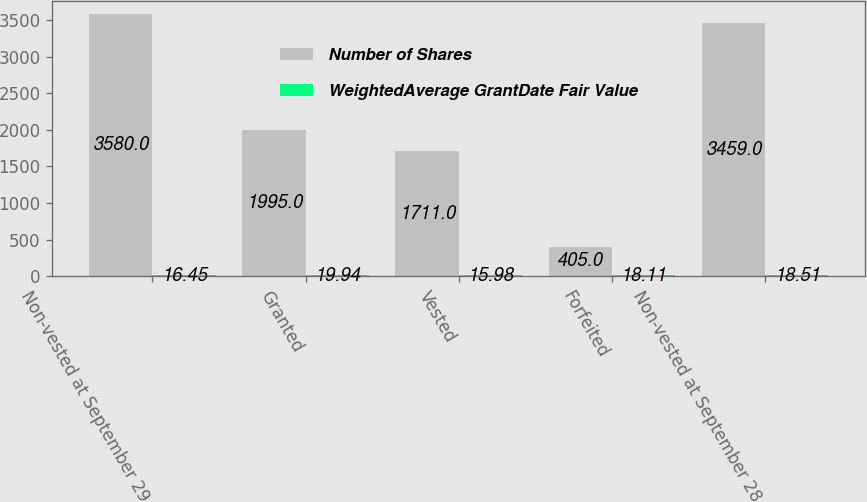Convert chart. <chart><loc_0><loc_0><loc_500><loc_500><stacked_bar_chart><ecel><fcel>Non-vested at September 29<fcel>Granted<fcel>Vested<fcel>Forfeited<fcel>Non-vested at September 28<nl><fcel>Number of Shares<fcel>3580<fcel>1995<fcel>1711<fcel>405<fcel>3459<nl><fcel>WeightedAverage GrantDate Fair Value<fcel>16.45<fcel>19.94<fcel>15.98<fcel>18.11<fcel>18.51<nl></chart> 